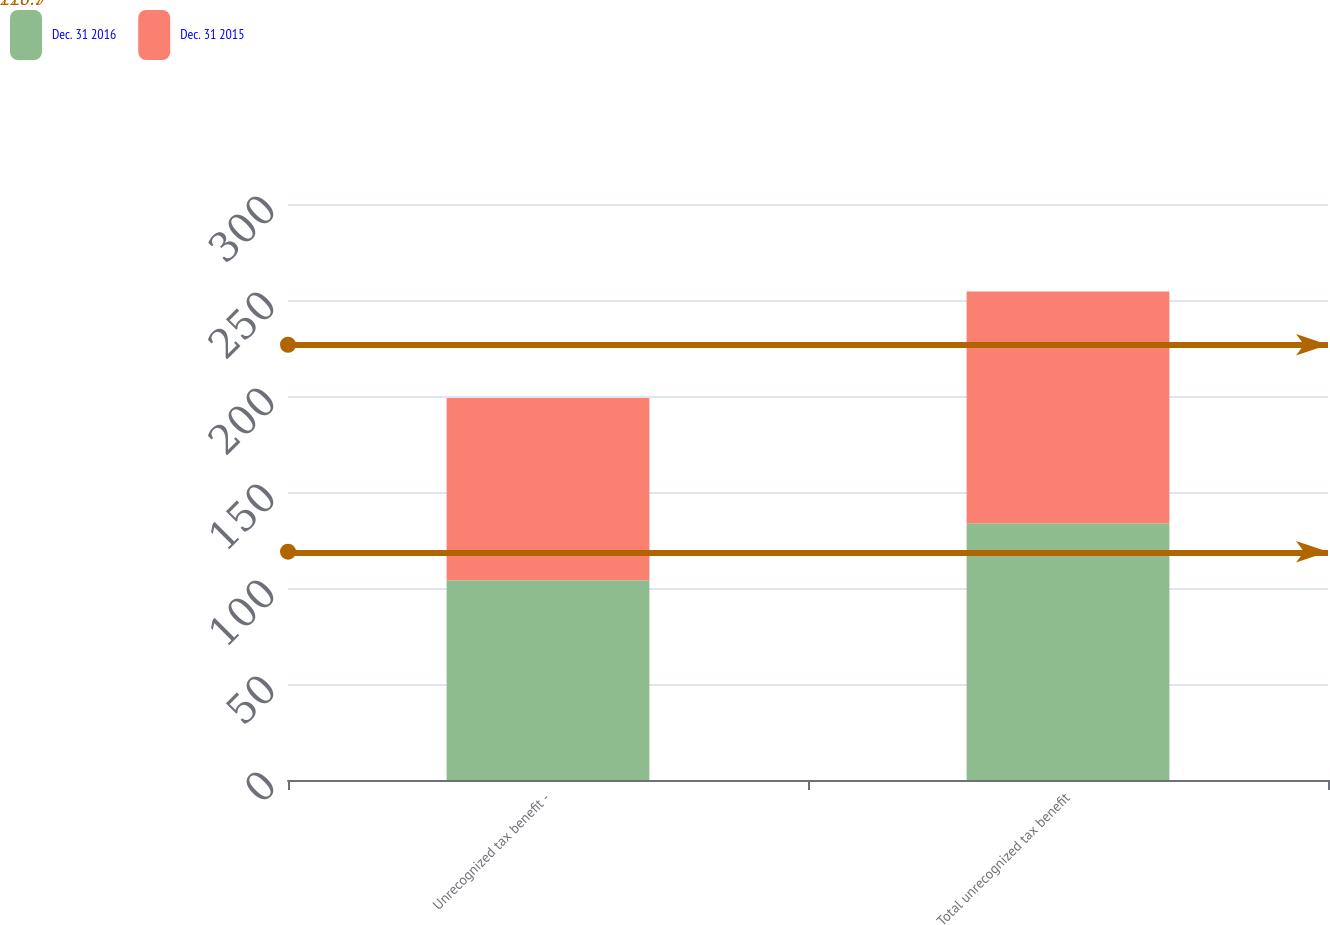<chart> <loc_0><loc_0><loc_500><loc_500><stacked_bar_chart><ecel><fcel>Unrecognized tax benefit -<fcel>Total unrecognized tax benefit<nl><fcel>Dec. 31 2016<fcel>104.1<fcel>133.7<nl><fcel>Dec. 31 2015<fcel>94.9<fcel>120.7<nl></chart> 